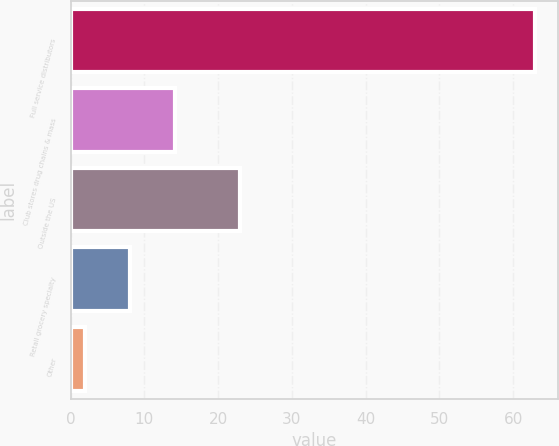<chart> <loc_0><loc_0><loc_500><loc_500><bar_chart><fcel>Full service distributors<fcel>Club stores drug chains & mass<fcel>Outside the US<fcel>Retail grocery specialty<fcel>Other<nl><fcel>63<fcel>14.2<fcel>23<fcel>8.1<fcel>2<nl></chart> 